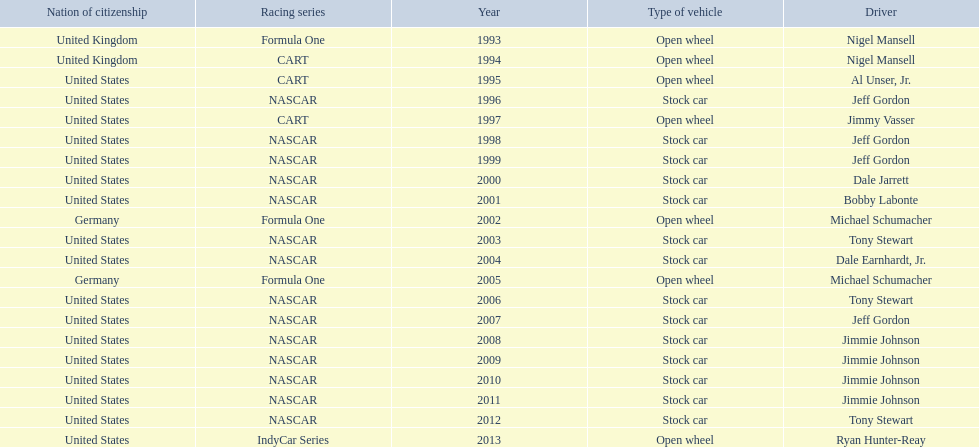Who won an espy in the year 2004, bobby labonte, tony stewart, dale earnhardt jr., or jeff gordon? Dale Earnhardt, Jr. Who won the espy in the year 1997; nigel mansell, al unser, jr., jeff gordon, or jimmy vasser? Jimmy Vasser. Which one only has one espy; nigel mansell, al unser jr., michael schumacher, or jeff gordon? Al Unser, Jr. 